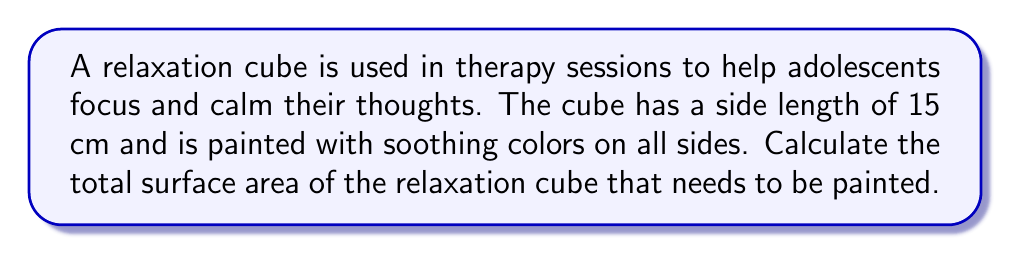Give your solution to this math problem. To solve this problem, we need to follow these steps:

1. Recall the formula for the surface area of a cube:
   $$SA = 6s^2$$
   where $SA$ is the surface area and $s$ is the length of one side of the cube.

2. We are given that the side length of the relaxation cube is 15 cm. Let's substitute this into our formula:
   $$SA = 6 \times (15\text{ cm})^2$$

3. Now, let's calculate:
   $$\begin{align}
   SA &= 6 \times (15\text{ cm})^2 \\
   &= 6 \times 225\text{ cm}^2 \\
   &= 1350\text{ cm}^2
   \end{align}$$

4. Therefore, the total surface area of the relaxation cube that needs to be painted is 1350 square centimeters.

[asy]
import three;
size(200);
currentprojection=perspective(6,3,2);
triple A=(0,0,0), B=(15,0,0), C=(15,15,0), D=(0,15,0), E=(0,0,15), F=(15,0,15), G=(15,15,15), H=(0,15,15);
draw(A--B--C--D--cycle);
draw(E--F--G--H--cycle);
draw(A--E);
draw(B--F);
draw(C--G);
draw(D--H);
label("15 cm", (B+C)/2, S);
label("15 cm", (C+G)/2, E);
label("15 cm", (G+H)/2, N);
[/asy]
Answer: $1350\text{ cm}^2$ 